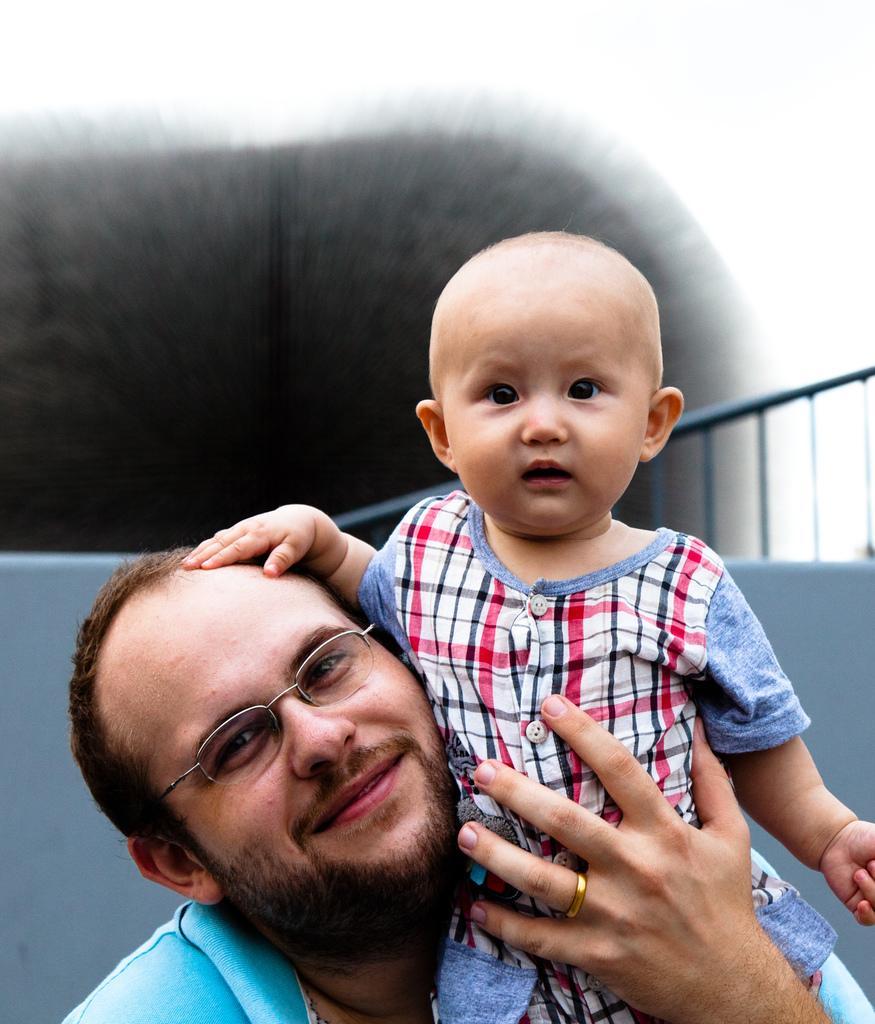How would you summarize this image in a sentence or two? In this image we can see a man holding a child in the hands. 